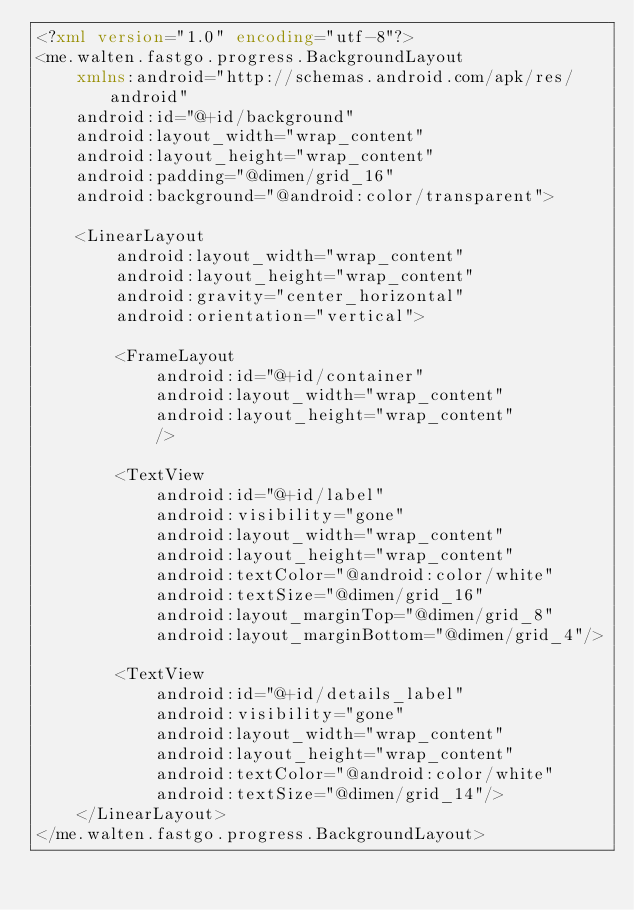Convert code to text. <code><loc_0><loc_0><loc_500><loc_500><_XML_><?xml version="1.0" encoding="utf-8"?>
<me.walten.fastgo.progress.BackgroundLayout
    xmlns:android="http://schemas.android.com/apk/res/android"
    android:id="@+id/background"
    android:layout_width="wrap_content"
    android:layout_height="wrap_content"
    android:padding="@dimen/grid_16"
    android:background="@android:color/transparent">

    <LinearLayout
        android:layout_width="wrap_content"
        android:layout_height="wrap_content"
        android:gravity="center_horizontal"
        android:orientation="vertical">

        <FrameLayout
            android:id="@+id/container"
            android:layout_width="wrap_content"
            android:layout_height="wrap_content"
            />

        <TextView
            android:id="@+id/label"
            android:visibility="gone"
            android:layout_width="wrap_content"
            android:layout_height="wrap_content"
            android:textColor="@android:color/white"
            android:textSize="@dimen/grid_16"
            android:layout_marginTop="@dimen/grid_8"
            android:layout_marginBottom="@dimen/grid_4"/>

        <TextView
            android:id="@+id/details_label"
            android:visibility="gone"
            android:layout_width="wrap_content"
            android:layout_height="wrap_content"
            android:textColor="@android:color/white"
            android:textSize="@dimen/grid_14"/>
    </LinearLayout>
</me.walten.fastgo.progress.BackgroundLayout></code> 